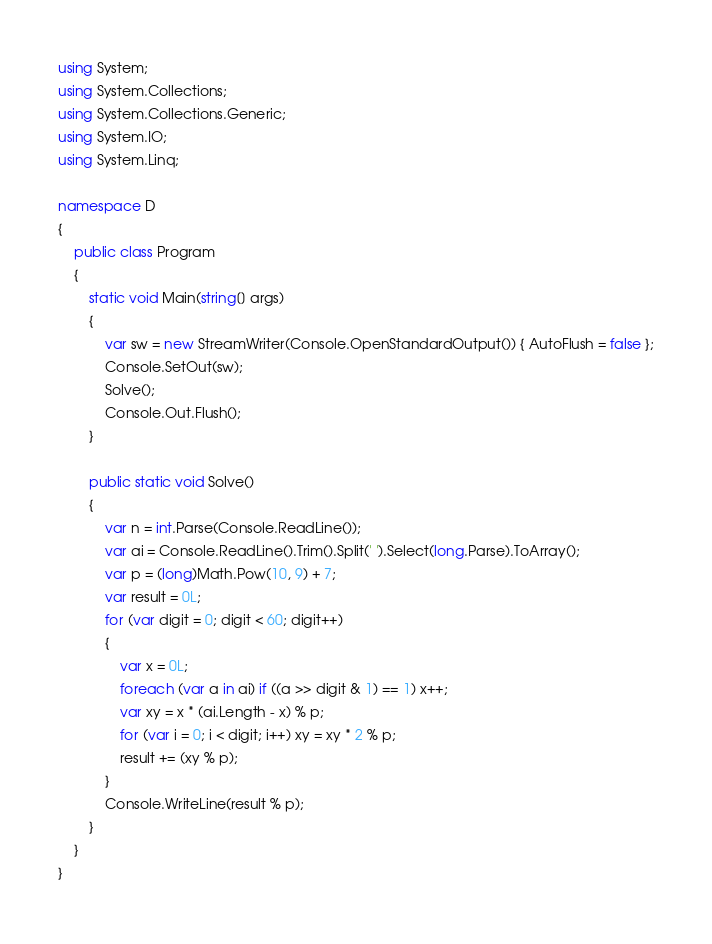Convert code to text. <code><loc_0><loc_0><loc_500><loc_500><_C#_>using System;
using System.Collections;
using System.Collections.Generic;
using System.IO;
using System.Linq;

namespace D
{
    public class Program
    {
        static void Main(string[] args)
        {
            var sw = new StreamWriter(Console.OpenStandardOutput()) { AutoFlush = false };
            Console.SetOut(sw);
            Solve();
            Console.Out.Flush();
        }

        public static void Solve()
        {
            var n = int.Parse(Console.ReadLine());
            var ai = Console.ReadLine().Trim().Split(' ').Select(long.Parse).ToArray();
            var p = (long)Math.Pow(10, 9) + 7;
            var result = 0L;
            for (var digit = 0; digit < 60; digit++)
            {
                var x = 0L;
                foreach (var a in ai) if ((a >> digit & 1) == 1) x++;
                var xy = x * (ai.Length - x) % p;
                for (var i = 0; i < digit; i++) xy = xy * 2 % p;
                result += (xy % p);
            }
            Console.WriteLine(result % p);
        }
    }
}
</code> 